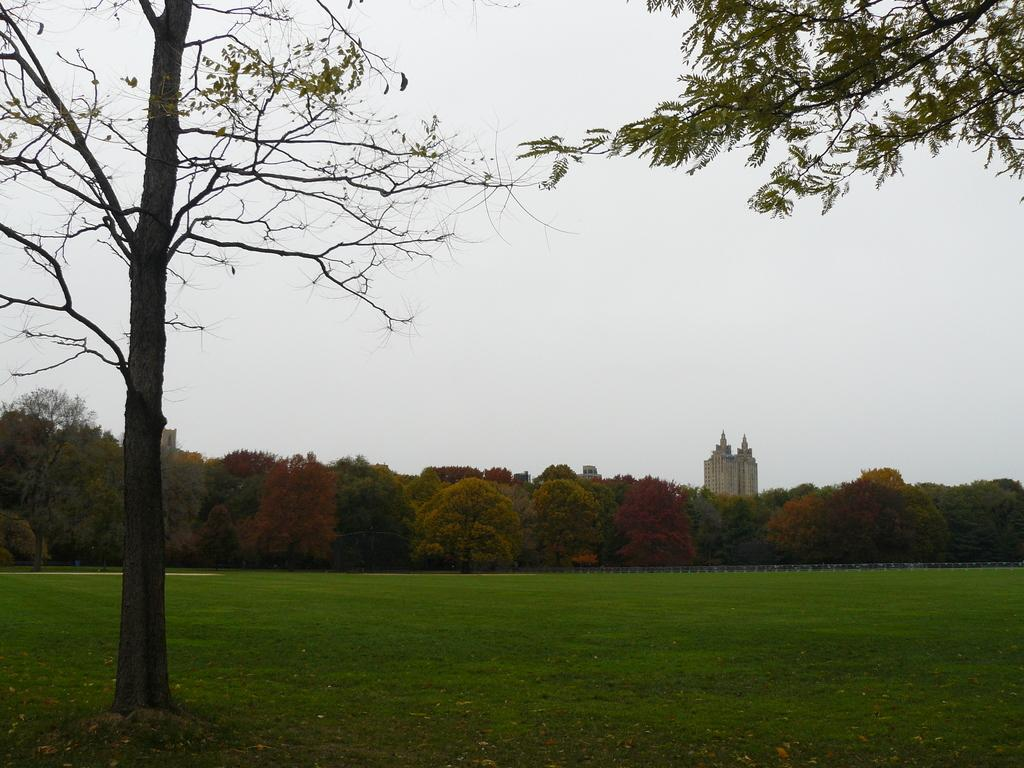What type of vegetation can be seen in the image? There are trees in the image. What else can be seen on the ground in the image? There is grass in the image. What type of structure is present in the image? There is a building in the image. What is visible in the background of the image? The sky is visible in the image. How many bulbs are hanging from the trees in the image? There are no bulbs present in the image; it features trees, grass, a building, and the sky. What color are the eyes of the representative in the image? There is no representative present in the image, so it is not possible to determine the color of their eyes. 